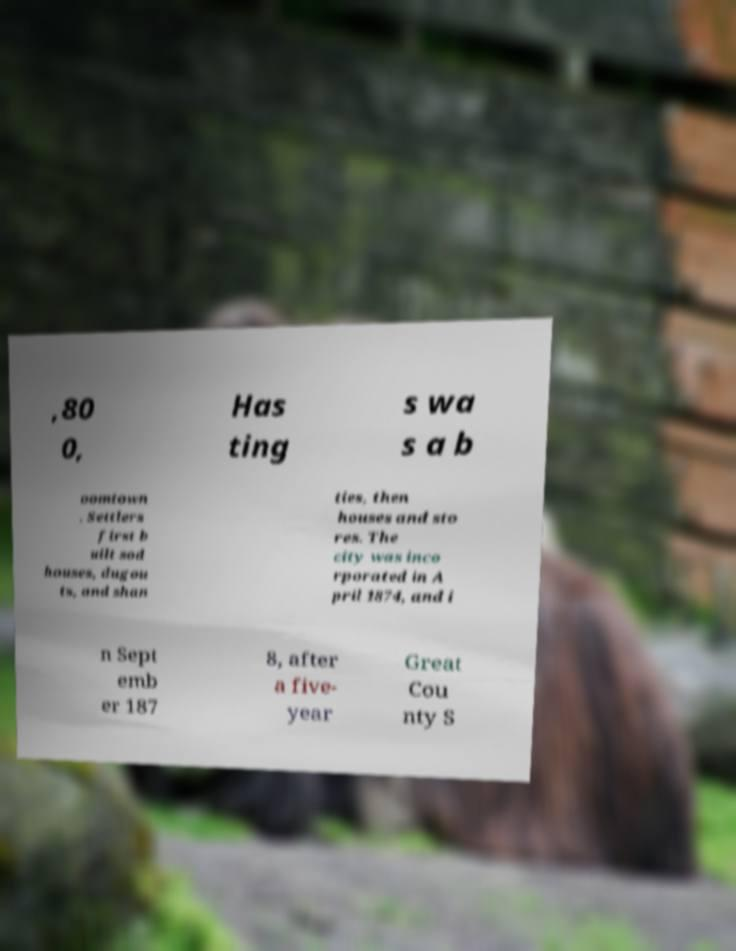Can you read and provide the text displayed in the image?This photo seems to have some interesting text. Can you extract and type it out for me? ,80 0, Has ting s wa s a b oomtown . Settlers first b uilt sod houses, dugou ts, and shan ties, then houses and sto res. The city was inco rporated in A pril 1874, and i n Sept emb er 187 8, after a five- year Great Cou nty S 